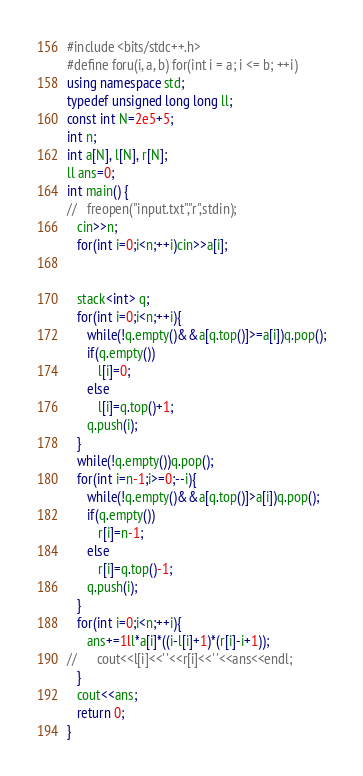Convert code to text. <code><loc_0><loc_0><loc_500><loc_500><_C++_>#include <bits/stdc++.h>
#define foru(i, a, b) for(int i = a; i <= b; ++i)
using namespace std;
typedef unsigned long long ll;
const int N=2e5+5;
int n;
int a[N], l[N], r[N];
ll ans=0;
int main() {
//   freopen("input.txt","r",stdin);
   cin>>n;
   for(int i=0;i<n;++i)cin>>a[i];


   stack<int> q;
   for(int i=0;i<n;++i){
      while(!q.empty()&&a[q.top()]>=a[i])q.pop();
      if(q.empty())
         l[i]=0;
      else
         l[i]=q.top()+1;
      q.push(i);
   }
   while(!q.empty())q.pop();
   for(int i=n-1;i>=0;--i){
      while(!q.empty()&&a[q.top()]>a[i])q.pop();
      if(q.empty())
         r[i]=n-1;
      else
         r[i]=q.top()-1;
      q.push(i);
   }
   for(int i=0;i<n;++i){
      ans+=1ll*a[i]*((i-l[i]+1)*(r[i]-i+1));
//      cout<<l[i]<<' '<<r[i]<<' '<<ans<<endl;
   }
   cout<<ans;
   return 0;
}
</code> 